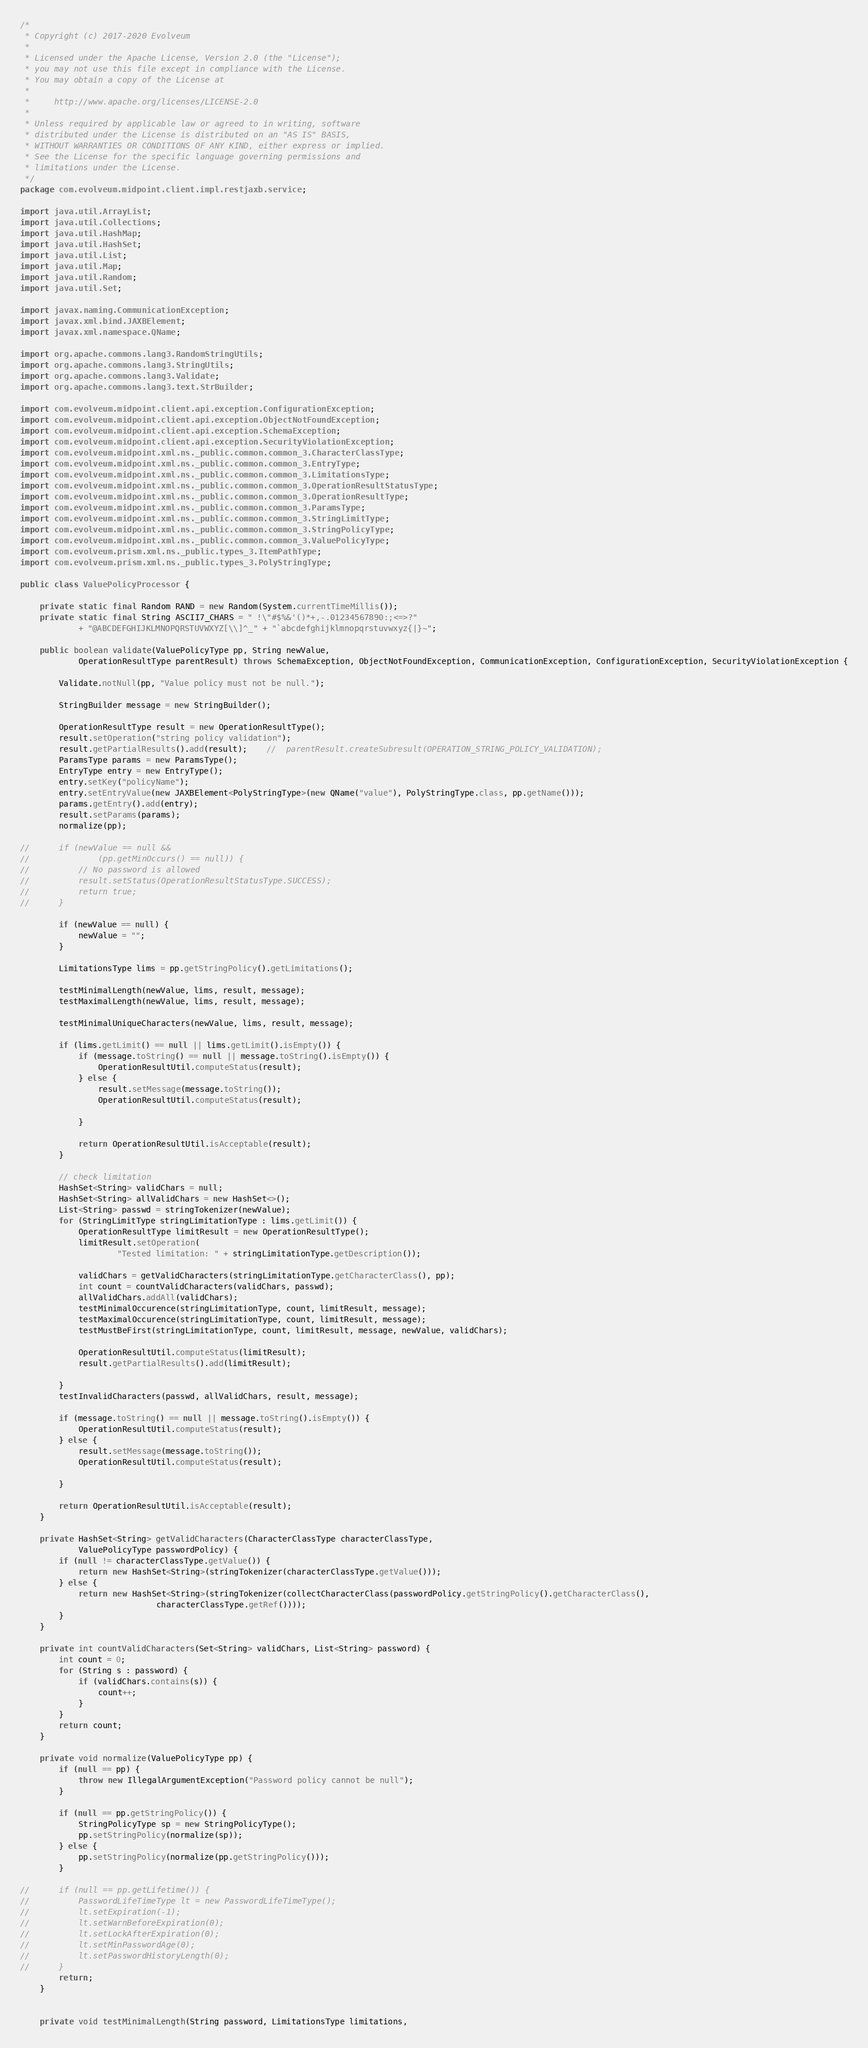Convert code to text. <code><loc_0><loc_0><loc_500><loc_500><_Java_>/*
 * Copyright (c) 2017-2020 Evolveum
 *
 * Licensed under the Apache License, Version 2.0 (the "License");
 * you may not use this file except in compliance with the License.
 * You may obtain a copy of the License at
 *
 *     http://www.apache.org/licenses/LICENSE-2.0
 *
 * Unless required by applicable law or agreed to in writing, software
 * distributed under the License is distributed on an "AS IS" BASIS,
 * WITHOUT WARRANTIES OR CONDITIONS OF ANY KIND, either express or implied.
 * See the License for the specific language governing permissions and
 * limitations under the License.
 */
package com.evolveum.midpoint.client.impl.restjaxb.service;

import java.util.ArrayList;
import java.util.Collections;
import java.util.HashMap;
import java.util.HashSet;
import java.util.List;
import java.util.Map;
import java.util.Random;
import java.util.Set;

import javax.naming.CommunicationException;
import javax.xml.bind.JAXBElement;
import javax.xml.namespace.QName;

import org.apache.commons.lang3.RandomStringUtils;
import org.apache.commons.lang3.StringUtils;
import org.apache.commons.lang3.Validate;
import org.apache.commons.lang3.text.StrBuilder;

import com.evolveum.midpoint.client.api.exception.ConfigurationException;
import com.evolveum.midpoint.client.api.exception.ObjectNotFoundException;
import com.evolveum.midpoint.client.api.exception.SchemaException;
import com.evolveum.midpoint.client.api.exception.SecurityViolationException;
import com.evolveum.midpoint.xml.ns._public.common.common_3.CharacterClassType;
import com.evolveum.midpoint.xml.ns._public.common.common_3.EntryType;
import com.evolveum.midpoint.xml.ns._public.common.common_3.LimitationsType;
import com.evolveum.midpoint.xml.ns._public.common.common_3.OperationResultStatusType;
import com.evolveum.midpoint.xml.ns._public.common.common_3.OperationResultType;
import com.evolveum.midpoint.xml.ns._public.common.common_3.ParamsType;
import com.evolveum.midpoint.xml.ns._public.common.common_3.StringLimitType;
import com.evolveum.midpoint.xml.ns._public.common.common_3.StringPolicyType;
import com.evolveum.midpoint.xml.ns._public.common.common_3.ValuePolicyType;
import com.evolveum.prism.xml.ns._public.types_3.ItemPathType;
import com.evolveum.prism.xml.ns._public.types_3.PolyStringType;

public class ValuePolicyProcessor {

	private static final Random RAND = new Random(System.currentTimeMillis());
	private static final String ASCII7_CHARS = " !\"#$%&'()*+,-.01234567890:;<=>?"
			+ "@ABCDEFGHIJKLMNOPQRSTUVWXYZ[\\]^_" + "`abcdefghijklmnopqrstuvwxyz{|}~";

	public boolean validate(ValuePolicyType pp, String newValue,
			OperationResultType parentResult) throws SchemaException, ObjectNotFoundException, CommunicationException, ConfigurationException, SecurityViolationException {

		Validate.notNull(pp, "Value policy must not be null.");

		StringBuilder message = new StringBuilder();

		OperationResultType result = new OperationResultType();
		result.setOperation("string policy validation");
		result.getPartialResults().add(result);	//	parentResult.createSubresult(OPERATION_STRING_POLICY_VALIDATION);
		ParamsType params = new ParamsType();
		EntryType entry = new EntryType();
		entry.setKey("policyName");
		entry.setEntryValue(new JAXBElement<PolyStringType>(new QName("value"), PolyStringType.class, pp.getName()));
		params.getEntry().add(entry);
		result.setParams(params);
		normalize(pp);

//		if (newValue == null &&
//				(pp.getMinOccurs() == null)) {
//			// No password is allowed
//			result.setStatus(OperationResultStatusType.SUCCESS);
//			return true;
//		}

		if (newValue == null) {
			newValue = "";
		}

		LimitationsType lims = pp.getStringPolicy().getLimitations();

		testMinimalLength(newValue, lims, result, message);
		testMaximalLength(newValue, lims, result, message);

		testMinimalUniqueCharacters(newValue, lims, result, message);

		if (lims.getLimit() == null || lims.getLimit().isEmpty()) {
			if (message.toString() == null || message.toString().isEmpty()) {
				OperationResultUtil.computeStatus(result);
			} else {
				result.setMessage(message.toString());
				OperationResultUtil.computeStatus(result);

			}

			return OperationResultUtil.isAcceptable(result);
		}

		// check limitation
		HashSet<String> validChars = null;
		HashSet<String> allValidChars = new HashSet<>();
		List<String> passwd = stringTokenizer(newValue);
		for (StringLimitType stringLimitationType : lims.getLimit()) {
			OperationResultType limitResult = new OperationResultType();
			limitResult.setOperation(
					"Tested limitation: " + stringLimitationType.getDescription());

			validChars = getValidCharacters(stringLimitationType.getCharacterClass(), pp);
			int count = countValidCharacters(validChars, passwd);
			allValidChars.addAll(validChars);
			testMinimalOccurence(stringLimitationType, count, limitResult, message);
			testMaximalOccurence(stringLimitationType, count, limitResult, message);
			testMustBeFirst(stringLimitationType, count, limitResult, message, newValue, validChars);

			OperationResultUtil.computeStatus(limitResult);
			result.getPartialResults().add(limitResult);

		}
		testInvalidCharacters(passwd, allValidChars, result, message);

		if (message.toString() == null || message.toString().isEmpty()) {
			OperationResultUtil.computeStatus(result);
		} else {
			result.setMessage(message.toString());
			OperationResultUtil.computeStatus(result);

		}

		return OperationResultUtil.isAcceptable(result);
	}

	private HashSet<String> getValidCharacters(CharacterClassType characterClassType,
			ValuePolicyType passwordPolicy) {
		if (null != characterClassType.getValue()) {
			return new HashSet<String>(stringTokenizer(characterClassType.getValue()));
		} else {
			return new HashSet<String>(stringTokenizer(collectCharacterClass(passwordPolicy.getStringPolicy().getCharacterClass(),
							characterClassType.getRef())));
		}
	}

	private int countValidCharacters(Set<String> validChars, List<String> password) {
		int count = 0;
		for (String s : password) {
			if (validChars.contains(s)) {
				count++;
			}
		}
		return count;
	}

	private void normalize(ValuePolicyType pp) {
		if (null == pp) {
			throw new IllegalArgumentException("Password policy cannot be null");
		}

		if (null == pp.getStringPolicy()) {
			StringPolicyType sp = new StringPolicyType();
			pp.setStringPolicy(normalize(sp));
		} else {
			pp.setStringPolicy(normalize(pp.getStringPolicy()));
		}

//		if (null == pp.getLifetime()) {
//			PasswordLifeTimeType lt = new PasswordLifeTimeType();
//			lt.setExpiration(-1);
//			lt.setWarnBeforeExpiration(0);
//			lt.setLockAfterExpiration(0);
//			lt.setMinPasswordAge(0);
//			lt.setPasswordHistoryLength(0);
//		}
		return;
	}


	private void testMinimalLength(String password, LimitationsType limitations,</code> 